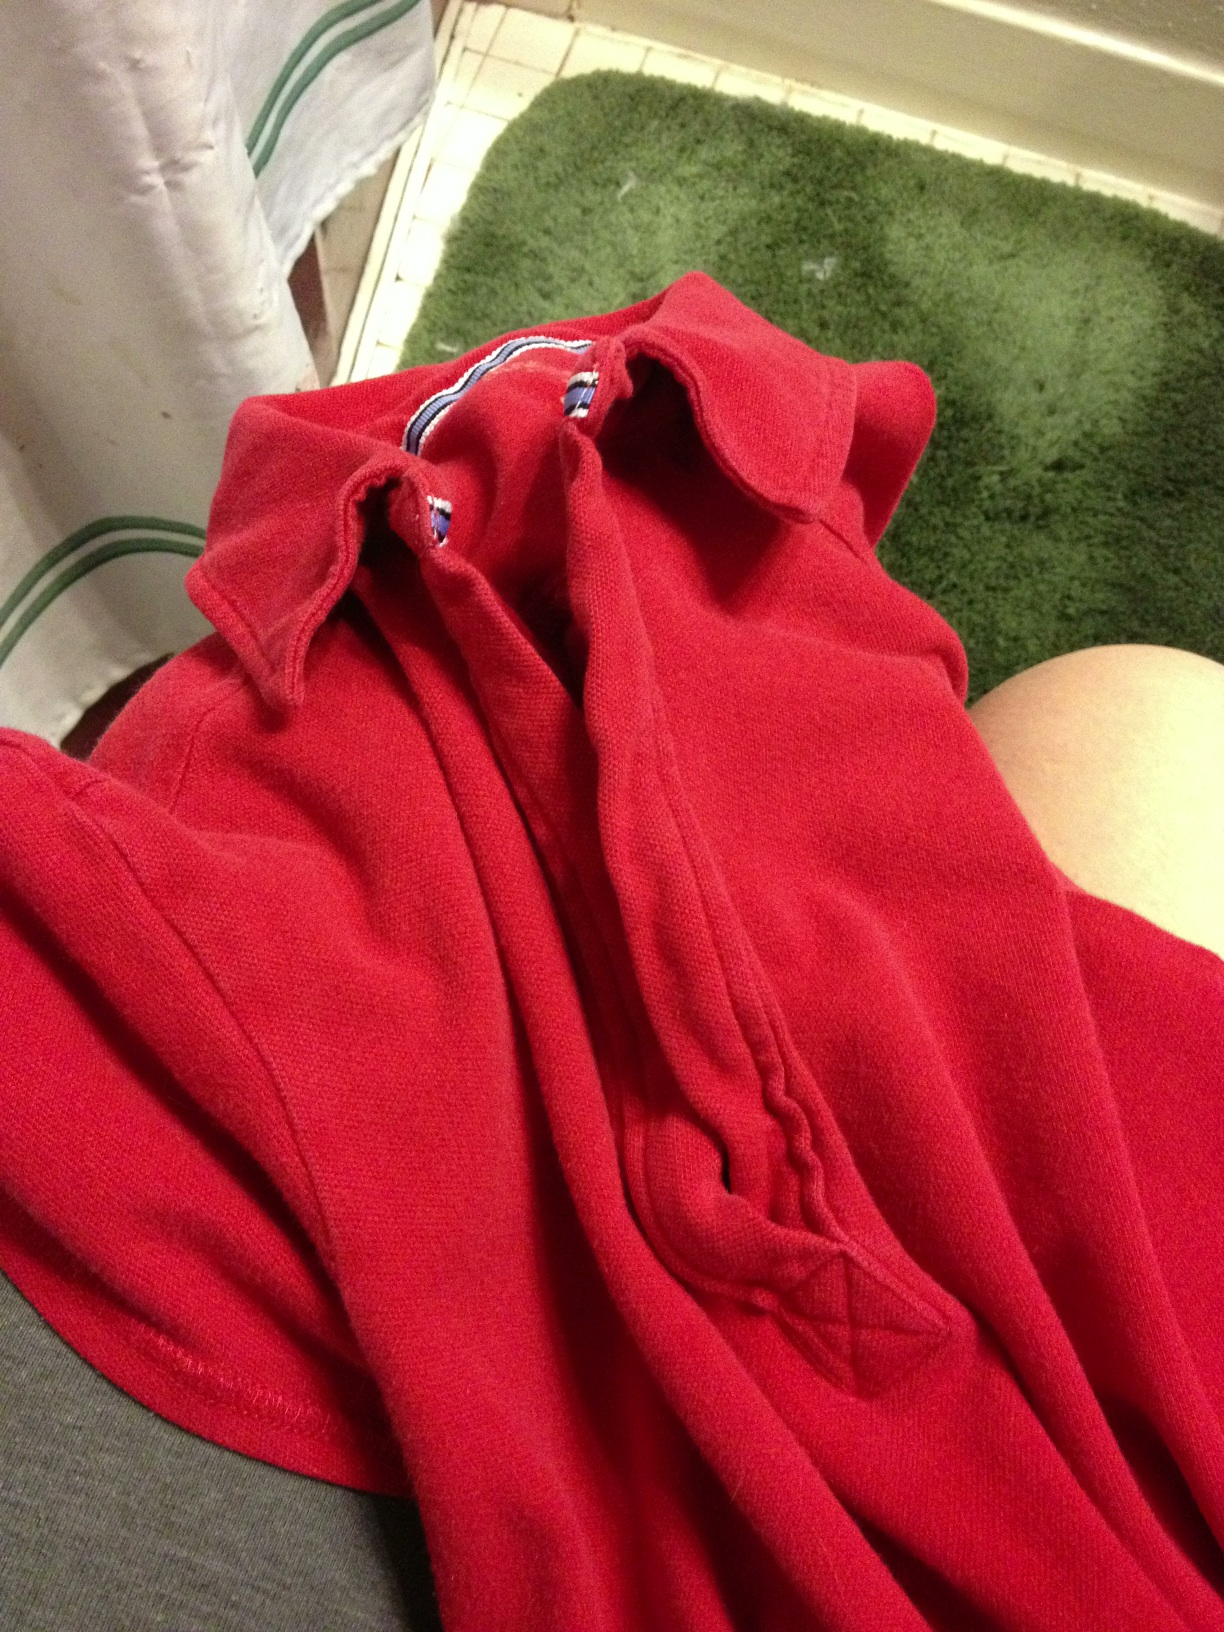Is this shirt suitable for formal events or casual wear? Given the style and color of the shirt, it's best suited for casual wear and would pair well with denim or casual trousers. 